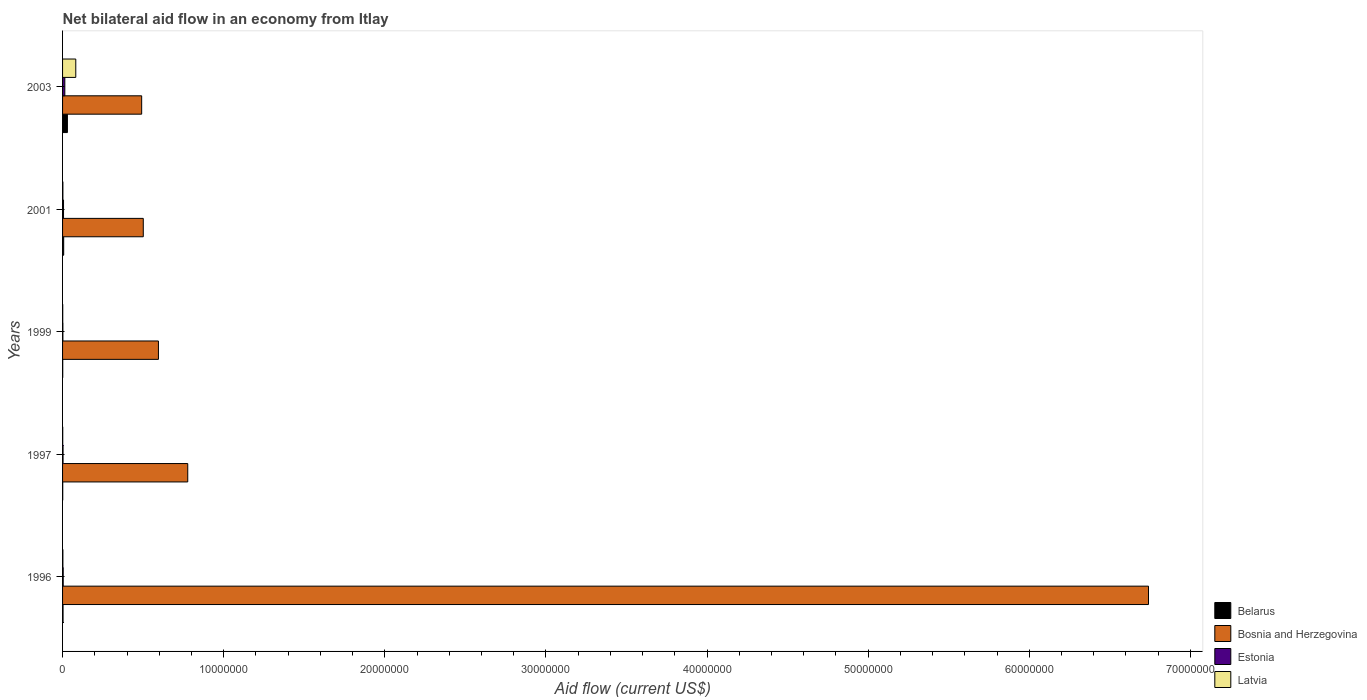How many different coloured bars are there?
Keep it short and to the point. 4. How many groups of bars are there?
Offer a terse response. 5. Are the number of bars per tick equal to the number of legend labels?
Provide a short and direct response. Yes. Are the number of bars on each tick of the Y-axis equal?
Give a very brief answer. Yes. How many bars are there on the 1st tick from the top?
Make the answer very short. 4. How many bars are there on the 4th tick from the bottom?
Offer a terse response. 4. What is the net bilateral aid flow in Belarus in 1999?
Provide a succinct answer. 10000. Across all years, what is the maximum net bilateral aid flow in Bosnia and Herzegovina?
Make the answer very short. 6.74e+07. Across all years, what is the minimum net bilateral aid flow in Estonia?
Provide a short and direct response. 2.00e+04. What is the total net bilateral aid flow in Belarus in the graph?
Ensure brevity in your answer.  4.20e+05. What is the difference between the net bilateral aid flow in Bosnia and Herzegovina in 1997 and that in 2003?
Offer a terse response. 2.86e+06. What is the average net bilateral aid flow in Bosnia and Herzegovina per year?
Offer a very short reply. 1.82e+07. In the year 2003, what is the difference between the net bilateral aid flow in Latvia and net bilateral aid flow in Belarus?
Your response must be concise. 5.20e+05. In how many years, is the net bilateral aid flow in Belarus greater than 68000000 US$?
Provide a succinct answer. 0. What is the ratio of the net bilateral aid flow in Latvia in 1997 to that in 2001?
Ensure brevity in your answer.  0.5. Is the net bilateral aid flow in Estonia in 2001 less than that in 2003?
Make the answer very short. Yes. Is the difference between the net bilateral aid flow in Latvia in 1996 and 1999 greater than the difference between the net bilateral aid flow in Belarus in 1996 and 1999?
Your response must be concise. No. What is the difference between the highest and the second highest net bilateral aid flow in Bosnia and Herzegovina?
Provide a succinct answer. 5.96e+07. In how many years, is the net bilateral aid flow in Estonia greater than the average net bilateral aid flow in Estonia taken over all years?
Your answer should be compact. 2. What does the 2nd bar from the top in 1999 represents?
Ensure brevity in your answer.  Estonia. What does the 4th bar from the bottom in 1999 represents?
Keep it short and to the point. Latvia. Are all the bars in the graph horizontal?
Offer a terse response. Yes. How many years are there in the graph?
Your response must be concise. 5. What is the title of the graph?
Make the answer very short. Net bilateral aid flow in an economy from Itlay. What is the label or title of the Y-axis?
Offer a very short reply. Years. What is the Aid flow (current US$) in Bosnia and Herzegovina in 1996?
Provide a short and direct response. 6.74e+07. What is the Aid flow (current US$) in Estonia in 1996?
Give a very brief answer. 4.00e+04. What is the Aid flow (current US$) in Latvia in 1996?
Your answer should be very brief. 2.00e+04. What is the Aid flow (current US$) in Bosnia and Herzegovina in 1997?
Offer a very short reply. 7.77e+06. What is the Aid flow (current US$) in Estonia in 1997?
Offer a very short reply. 3.00e+04. What is the Aid flow (current US$) of Belarus in 1999?
Make the answer very short. 10000. What is the Aid flow (current US$) of Bosnia and Herzegovina in 1999?
Your answer should be very brief. 5.95e+06. What is the Aid flow (current US$) of Estonia in 1999?
Your answer should be very brief. 2.00e+04. What is the Aid flow (current US$) of Latvia in 1999?
Offer a very short reply. 10000. What is the Aid flow (current US$) of Bosnia and Herzegovina in 2001?
Give a very brief answer. 5.01e+06. What is the Aid flow (current US$) in Estonia in 2001?
Your answer should be very brief. 6.00e+04. What is the Aid flow (current US$) in Latvia in 2001?
Provide a succinct answer. 2.00e+04. What is the Aid flow (current US$) of Belarus in 2003?
Offer a very short reply. 3.00e+05. What is the Aid flow (current US$) of Bosnia and Herzegovina in 2003?
Your answer should be very brief. 4.91e+06. What is the Aid flow (current US$) in Latvia in 2003?
Give a very brief answer. 8.20e+05. Across all years, what is the maximum Aid flow (current US$) of Bosnia and Herzegovina?
Offer a terse response. 6.74e+07. Across all years, what is the maximum Aid flow (current US$) of Latvia?
Keep it short and to the point. 8.20e+05. Across all years, what is the minimum Aid flow (current US$) in Bosnia and Herzegovina?
Keep it short and to the point. 4.91e+06. Across all years, what is the minimum Aid flow (current US$) in Latvia?
Offer a very short reply. 10000. What is the total Aid flow (current US$) of Bosnia and Herzegovina in the graph?
Make the answer very short. 9.10e+07. What is the total Aid flow (current US$) of Estonia in the graph?
Your answer should be compact. 2.90e+05. What is the total Aid flow (current US$) in Latvia in the graph?
Ensure brevity in your answer.  8.80e+05. What is the difference between the Aid flow (current US$) in Bosnia and Herzegovina in 1996 and that in 1997?
Your answer should be compact. 5.96e+07. What is the difference between the Aid flow (current US$) in Latvia in 1996 and that in 1997?
Make the answer very short. 10000. What is the difference between the Aid flow (current US$) in Belarus in 1996 and that in 1999?
Keep it short and to the point. 2.00e+04. What is the difference between the Aid flow (current US$) of Bosnia and Herzegovina in 1996 and that in 1999?
Your response must be concise. 6.14e+07. What is the difference between the Aid flow (current US$) of Latvia in 1996 and that in 1999?
Your answer should be compact. 10000. What is the difference between the Aid flow (current US$) of Belarus in 1996 and that in 2001?
Offer a very short reply. -4.00e+04. What is the difference between the Aid flow (current US$) of Bosnia and Herzegovina in 1996 and that in 2001?
Ensure brevity in your answer.  6.24e+07. What is the difference between the Aid flow (current US$) in Latvia in 1996 and that in 2001?
Provide a short and direct response. 0. What is the difference between the Aid flow (current US$) of Bosnia and Herzegovina in 1996 and that in 2003?
Ensure brevity in your answer.  6.25e+07. What is the difference between the Aid flow (current US$) in Estonia in 1996 and that in 2003?
Ensure brevity in your answer.  -1.00e+05. What is the difference between the Aid flow (current US$) of Latvia in 1996 and that in 2003?
Offer a terse response. -8.00e+05. What is the difference between the Aid flow (current US$) in Belarus in 1997 and that in 1999?
Give a very brief answer. 0. What is the difference between the Aid flow (current US$) in Bosnia and Herzegovina in 1997 and that in 1999?
Provide a succinct answer. 1.82e+06. What is the difference between the Aid flow (current US$) of Estonia in 1997 and that in 1999?
Provide a succinct answer. 10000. What is the difference between the Aid flow (current US$) of Latvia in 1997 and that in 1999?
Ensure brevity in your answer.  0. What is the difference between the Aid flow (current US$) of Belarus in 1997 and that in 2001?
Ensure brevity in your answer.  -6.00e+04. What is the difference between the Aid flow (current US$) of Bosnia and Herzegovina in 1997 and that in 2001?
Offer a very short reply. 2.76e+06. What is the difference between the Aid flow (current US$) of Latvia in 1997 and that in 2001?
Ensure brevity in your answer.  -10000. What is the difference between the Aid flow (current US$) of Belarus in 1997 and that in 2003?
Make the answer very short. -2.90e+05. What is the difference between the Aid flow (current US$) of Bosnia and Herzegovina in 1997 and that in 2003?
Offer a very short reply. 2.86e+06. What is the difference between the Aid flow (current US$) of Latvia in 1997 and that in 2003?
Your answer should be very brief. -8.10e+05. What is the difference between the Aid flow (current US$) in Bosnia and Herzegovina in 1999 and that in 2001?
Offer a terse response. 9.40e+05. What is the difference between the Aid flow (current US$) in Latvia in 1999 and that in 2001?
Your response must be concise. -10000. What is the difference between the Aid flow (current US$) of Bosnia and Herzegovina in 1999 and that in 2003?
Provide a succinct answer. 1.04e+06. What is the difference between the Aid flow (current US$) in Estonia in 1999 and that in 2003?
Give a very brief answer. -1.20e+05. What is the difference between the Aid flow (current US$) in Latvia in 1999 and that in 2003?
Offer a very short reply. -8.10e+05. What is the difference between the Aid flow (current US$) in Latvia in 2001 and that in 2003?
Make the answer very short. -8.00e+05. What is the difference between the Aid flow (current US$) in Belarus in 1996 and the Aid flow (current US$) in Bosnia and Herzegovina in 1997?
Provide a succinct answer. -7.74e+06. What is the difference between the Aid flow (current US$) of Bosnia and Herzegovina in 1996 and the Aid flow (current US$) of Estonia in 1997?
Your answer should be very brief. 6.74e+07. What is the difference between the Aid flow (current US$) in Bosnia and Herzegovina in 1996 and the Aid flow (current US$) in Latvia in 1997?
Provide a short and direct response. 6.74e+07. What is the difference between the Aid flow (current US$) in Estonia in 1996 and the Aid flow (current US$) in Latvia in 1997?
Offer a terse response. 3.00e+04. What is the difference between the Aid flow (current US$) in Belarus in 1996 and the Aid flow (current US$) in Bosnia and Herzegovina in 1999?
Your answer should be very brief. -5.92e+06. What is the difference between the Aid flow (current US$) of Bosnia and Herzegovina in 1996 and the Aid flow (current US$) of Estonia in 1999?
Make the answer very short. 6.74e+07. What is the difference between the Aid flow (current US$) of Bosnia and Herzegovina in 1996 and the Aid flow (current US$) of Latvia in 1999?
Your response must be concise. 6.74e+07. What is the difference between the Aid flow (current US$) of Estonia in 1996 and the Aid flow (current US$) of Latvia in 1999?
Your answer should be very brief. 3.00e+04. What is the difference between the Aid flow (current US$) in Belarus in 1996 and the Aid flow (current US$) in Bosnia and Herzegovina in 2001?
Your answer should be compact. -4.98e+06. What is the difference between the Aid flow (current US$) in Belarus in 1996 and the Aid flow (current US$) in Estonia in 2001?
Make the answer very short. -3.00e+04. What is the difference between the Aid flow (current US$) of Belarus in 1996 and the Aid flow (current US$) of Latvia in 2001?
Give a very brief answer. 10000. What is the difference between the Aid flow (current US$) of Bosnia and Herzegovina in 1996 and the Aid flow (current US$) of Estonia in 2001?
Ensure brevity in your answer.  6.73e+07. What is the difference between the Aid flow (current US$) of Bosnia and Herzegovina in 1996 and the Aid flow (current US$) of Latvia in 2001?
Make the answer very short. 6.74e+07. What is the difference between the Aid flow (current US$) of Estonia in 1996 and the Aid flow (current US$) of Latvia in 2001?
Ensure brevity in your answer.  2.00e+04. What is the difference between the Aid flow (current US$) of Belarus in 1996 and the Aid flow (current US$) of Bosnia and Herzegovina in 2003?
Your response must be concise. -4.88e+06. What is the difference between the Aid flow (current US$) of Belarus in 1996 and the Aid flow (current US$) of Latvia in 2003?
Ensure brevity in your answer.  -7.90e+05. What is the difference between the Aid flow (current US$) of Bosnia and Herzegovina in 1996 and the Aid flow (current US$) of Estonia in 2003?
Your response must be concise. 6.73e+07. What is the difference between the Aid flow (current US$) of Bosnia and Herzegovina in 1996 and the Aid flow (current US$) of Latvia in 2003?
Your response must be concise. 6.66e+07. What is the difference between the Aid flow (current US$) of Estonia in 1996 and the Aid flow (current US$) of Latvia in 2003?
Provide a succinct answer. -7.80e+05. What is the difference between the Aid flow (current US$) of Belarus in 1997 and the Aid flow (current US$) of Bosnia and Herzegovina in 1999?
Provide a succinct answer. -5.94e+06. What is the difference between the Aid flow (current US$) in Belarus in 1997 and the Aid flow (current US$) in Estonia in 1999?
Make the answer very short. -10000. What is the difference between the Aid flow (current US$) of Belarus in 1997 and the Aid flow (current US$) of Latvia in 1999?
Keep it short and to the point. 0. What is the difference between the Aid flow (current US$) of Bosnia and Herzegovina in 1997 and the Aid flow (current US$) of Estonia in 1999?
Your answer should be compact. 7.75e+06. What is the difference between the Aid flow (current US$) in Bosnia and Herzegovina in 1997 and the Aid flow (current US$) in Latvia in 1999?
Ensure brevity in your answer.  7.76e+06. What is the difference between the Aid flow (current US$) of Belarus in 1997 and the Aid flow (current US$) of Bosnia and Herzegovina in 2001?
Provide a succinct answer. -5.00e+06. What is the difference between the Aid flow (current US$) in Belarus in 1997 and the Aid flow (current US$) in Estonia in 2001?
Provide a succinct answer. -5.00e+04. What is the difference between the Aid flow (current US$) of Bosnia and Herzegovina in 1997 and the Aid flow (current US$) of Estonia in 2001?
Provide a succinct answer. 7.71e+06. What is the difference between the Aid flow (current US$) in Bosnia and Herzegovina in 1997 and the Aid flow (current US$) in Latvia in 2001?
Give a very brief answer. 7.75e+06. What is the difference between the Aid flow (current US$) of Belarus in 1997 and the Aid flow (current US$) of Bosnia and Herzegovina in 2003?
Provide a short and direct response. -4.90e+06. What is the difference between the Aid flow (current US$) in Belarus in 1997 and the Aid flow (current US$) in Latvia in 2003?
Make the answer very short. -8.10e+05. What is the difference between the Aid flow (current US$) in Bosnia and Herzegovina in 1997 and the Aid flow (current US$) in Estonia in 2003?
Keep it short and to the point. 7.63e+06. What is the difference between the Aid flow (current US$) of Bosnia and Herzegovina in 1997 and the Aid flow (current US$) of Latvia in 2003?
Your response must be concise. 6.95e+06. What is the difference between the Aid flow (current US$) in Estonia in 1997 and the Aid flow (current US$) in Latvia in 2003?
Ensure brevity in your answer.  -7.90e+05. What is the difference between the Aid flow (current US$) in Belarus in 1999 and the Aid flow (current US$) in Bosnia and Herzegovina in 2001?
Make the answer very short. -5.00e+06. What is the difference between the Aid flow (current US$) in Belarus in 1999 and the Aid flow (current US$) in Estonia in 2001?
Keep it short and to the point. -5.00e+04. What is the difference between the Aid flow (current US$) in Belarus in 1999 and the Aid flow (current US$) in Latvia in 2001?
Your answer should be compact. -10000. What is the difference between the Aid flow (current US$) of Bosnia and Herzegovina in 1999 and the Aid flow (current US$) of Estonia in 2001?
Provide a short and direct response. 5.89e+06. What is the difference between the Aid flow (current US$) of Bosnia and Herzegovina in 1999 and the Aid flow (current US$) of Latvia in 2001?
Make the answer very short. 5.93e+06. What is the difference between the Aid flow (current US$) of Estonia in 1999 and the Aid flow (current US$) of Latvia in 2001?
Offer a terse response. 0. What is the difference between the Aid flow (current US$) in Belarus in 1999 and the Aid flow (current US$) in Bosnia and Herzegovina in 2003?
Offer a very short reply. -4.90e+06. What is the difference between the Aid flow (current US$) in Belarus in 1999 and the Aid flow (current US$) in Estonia in 2003?
Offer a very short reply. -1.30e+05. What is the difference between the Aid flow (current US$) of Belarus in 1999 and the Aid flow (current US$) of Latvia in 2003?
Provide a succinct answer. -8.10e+05. What is the difference between the Aid flow (current US$) of Bosnia and Herzegovina in 1999 and the Aid flow (current US$) of Estonia in 2003?
Your answer should be compact. 5.81e+06. What is the difference between the Aid flow (current US$) of Bosnia and Herzegovina in 1999 and the Aid flow (current US$) of Latvia in 2003?
Provide a succinct answer. 5.13e+06. What is the difference between the Aid flow (current US$) of Estonia in 1999 and the Aid flow (current US$) of Latvia in 2003?
Your answer should be very brief. -8.00e+05. What is the difference between the Aid flow (current US$) of Belarus in 2001 and the Aid flow (current US$) of Bosnia and Herzegovina in 2003?
Keep it short and to the point. -4.84e+06. What is the difference between the Aid flow (current US$) of Belarus in 2001 and the Aid flow (current US$) of Latvia in 2003?
Keep it short and to the point. -7.50e+05. What is the difference between the Aid flow (current US$) of Bosnia and Herzegovina in 2001 and the Aid flow (current US$) of Estonia in 2003?
Your answer should be very brief. 4.87e+06. What is the difference between the Aid flow (current US$) in Bosnia and Herzegovina in 2001 and the Aid flow (current US$) in Latvia in 2003?
Your response must be concise. 4.19e+06. What is the difference between the Aid flow (current US$) of Estonia in 2001 and the Aid flow (current US$) of Latvia in 2003?
Offer a very short reply. -7.60e+05. What is the average Aid flow (current US$) of Belarus per year?
Ensure brevity in your answer.  8.40e+04. What is the average Aid flow (current US$) of Bosnia and Herzegovina per year?
Make the answer very short. 1.82e+07. What is the average Aid flow (current US$) of Estonia per year?
Keep it short and to the point. 5.80e+04. What is the average Aid flow (current US$) in Latvia per year?
Make the answer very short. 1.76e+05. In the year 1996, what is the difference between the Aid flow (current US$) of Belarus and Aid flow (current US$) of Bosnia and Herzegovina?
Your response must be concise. -6.74e+07. In the year 1996, what is the difference between the Aid flow (current US$) in Belarus and Aid flow (current US$) in Latvia?
Keep it short and to the point. 10000. In the year 1996, what is the difference between the Aid flow (current US$) in Bosnia and Herzegovina and Aid flow (current US$) in Estonia?
Provide a succinct answer. 6.74e+07. In the year 1996, what is the difference between the Aid flow (current US$) in Bosnia and Herzegovina and Aid flow (current US$) in Latvia?
Give a very brief answer. 6.74e+07. In the year 1997, what is the difference between the Aid flow (current US$) of Belarus and Aid flow (current US$) of Bosnia and Herzegovina?
Your answer should be very brief. -7.76e+06. In the year 1997, what is the difference between the Aid flow (current US$) in Belarus and Aid flow (current US$) in Estonia?
Make the answer very short. -2.00e+04. In the year 1997, what is the difference between the Aid flow (current US$) of Belarus and Aid flow (current US$) of Latvia?
Provide a succinct answer. 0. In the year 1997, what is the difference between the Aid flow (current US$) of Bosnia and Herzegovina and Aid flow (current US$) of Estonia?
Keep it short and to the point. 7.74e+06. In the year 1997, what is the difference between the Aid flow (current US$) of Bosnia and Herzegovina and Aid flow (current US$) of Latvia?
Give a very brief answer. 7.76e+06. In the year 1999, what is the difference between the Aid flow (current US$) in Belarus and Aid flow (current US$) in Bosnia and Herzegovina?
Offer a very short reply. -5.94e+06. In the year 1999, what is the difference between the Aid flow (current US$) in Belarus and Aid flow (current US$) in Estonia?
Make the answer very short. -10000. In the year 1999, what is the difference between the Aid flow (current US$) of Bosnia and Herzegovina and Aid flow (current US$) of Estonia?
Offer a very short reply. 5.93e+06. In the year 1999, what is the difference between the Aid flow (current US$) in Bosnia and Herzegovina and Aid flow (current US$) in Latvia?
Your answer should be very brief. 5.94e+06. In the year 2001, what is the difference between the Aid flow (current US$) of Belarus and Aid flow (current US$) of Bosnia and Herzegovina?
Provide a short and direct response. -4.94e+06. In the year 2001, what is the difference between the Aid flow (current US$) of Belarus and Aid flow (current US$) of Latvia?
Offer a very short reply. 5.00e+04. In the year 2001, what is the difference between the Aid flow (current US$) in Bosnia and Herzegovina and Aid flow (current US$) in Estonia?
Your answer should be compact. 4.95e+06. In the year 2001, what is the difference between the Aid flow (current US$) in Bosnia and Herzegovina and Aid flow (current US$) in Latvia?
Give a very brief answer. 4.99e+06. In the year 2001, what is the difference between the Aid flow (current US$) in Estonia and Aid flow (current US$) in Latvia?
Provide a short and direct response. 4.00e+04. In the year 2003, what is the difference between the Aid flow (current US$) in Belarus and Aid flow (current US$) in Bosnia and Herzegovina?
Your response must be concise. -4.61e+06. In the year 2003, what is the difference between the Aid flow (current US$) of Belarus and Aid flow (current US$) of Estonia?
Your answer should be compact. 1.60e+05. In the year 2003, what is the difference between the Aid flow (current US$) of Belarus and Aid flow (current US$) of Latvia?
Provide a short and direct response. -5.20e+05. In the year 2003, what is the difference between the Aid flow (current US$) in Bosnia and Herzegovina and Aid flow (current US$) in Estonia?
Ensure brevity in your answer.  4.77e+06. In the year 2003, what is the difference between the Aid flow (current US$) in Bosnia and Herzegovina and Aid flow (current US$) in Latvia?
Provide a succinct answer. 4.09e+06. In the year 2003, what is the difference between the Aid flow (current US$) of Estonia and Aid flow (current US$) of Latvia?
Your answer should be very brief. -6.80e+05. What is the ratio of the Aid flow (current US$) of Belarus in 1996 to that in 1997?
Give a very brief answer. 3. What is the ratio of the Aid flow (current US$) in Bosnia and Herzegovina in 1996 to that in 1997?
Your response must be concise. 8.67. What is the ratio of the Aid flow (current US$) of Latvia in 1996 to that in 1997?
Keep it short and to the point. 2. What is the ratio of the Aid flow (current US$) in Belarus in 1996 to that in 1999?
Your response must be concise. 3. What is the ratio of the Aid flow (current US$) in Bosnia and Herzegovina in 1996 to that in 1999?
Provide a short and direct response. 11.33. What is the ratio of the Aid flow (current US$) in Belarus in 1996 to that in 2001?
Keep it short and to the point. 0.43. What is the ratio of the Aid flow (current US$) of Bosnia and Herzegovina in 1996 to that in 2001?
Give a very brief answer. 13.45. What is the ratio of the Aid flow (current US$) in Belarus in 1996 to that in 2003?
Make the answer very short. 0.1. What is the ratio of the Aid flow (current US$) of Bosnia and Herzegovina in 1996 to that in 2003?
Keep it short and to the point. 13.73. What is the ratio of the Aid flow (current US$) in Estonia in 1996 to that in 2003?
Make the answer very short. 0.29. What is the ratio of the Aid flow (current US$) of Latvia in 1996 to that in 2003?
Give a very brief answer. 0.02. What is the ratio of the Aid flow (current US$) of Bosnia and Herzegovina in 1997 to that in 1999?
Offer a very short reply. 1.31. What is the ratio of the Aid flow (current US$) in Belarus in 1997 to that in 2001?
Make the answer very short. 0.14. What is the ratio of the Aid flow (current US$) in Bosnia and Herzegovina in 1997 to that in 2001?
Your answer should be compact. 1.55. What is the ratio of the Aid flow (current US$) of Estonia in 1997 to that in 2001?
Your answer should be very brief. 0.5. What is the ratio of the Aid flow (current US$) in Latvia in 1997 to that in 2001?
Offer a terse response. 0.5. What is the ratio of the Aid flow (current US$) of Bosnia and Herzegovina in 1997 to that in 2003?
Ensure brevity in your answer.  1.58. What is the ratio of the Aid flow (current US$) in Estonia in 1997 to that in 2003?
Offer a terse response. 0.21. What is the ratio of the Aid flow (current US$) of Latvia in 1997 to that in 2003?
Offer a terse response. 0.01. What is the ratio of the Aid flow (current US$) of Belarus in 1999 to that in 2001?
Your answer should be compact. 0.14. What is the ratio of the Aid flow (current US$) of Bosnia and Herzegovina in 1999 to that in 2001?
Your answer should be very brief. 1.19. What is the ratio of the Aid flow (current US$) in Belarus in 1999 to that in 2003?
Your response must be concise. 0.03. What is the ratio of the Aid flow (current US$) of Bosnia and Herzegovina in 1999 to that in 2003?
Provide a short and direct response. 1.21. What is the ratio of the Aid flow (current US$) in Estonia in 1999 to that in 2003?
Make the answer very short. 0.14. What is the ratio of the Aid flow (current US$) in Latvia in 1999 to that in 2003?
Ensure brevity in your answer.  0.01. What is the ratio of the Aid flow (current US$) in Belarus in 2001 to that in 2003?
Make the answer very short. 0.23. What is the ratio of the Aid flow (current US$) of Bosnia and Herzegovina in 2001 to that in 2003?
Make the answer very short. 1.02. What is the ratio of the Aid flow (current US$) in Estonia in 2001 to that in 2003?
Offer a very short reply. 0.43. What is the ratio of the Aid flow (current US$) in Latvia in 2001 to that in 2003?
Ensure brevity in your answer.  0.02. What is the difference between the highest and the second highest Aid flow (current US$) of Bosnia and Herzegovina?
Provide a succinct answer. 5.96e+07. What is the difference between the highest and the second highest Aid flow (current US$) of Estonia?
Provide a succinct answer. 8.00e+04. What is the difference between the highest and the lowest Aid flow (current US$) of Belarus?
Keep it short and to the point. 2.90e+05. What is the difference between the highest and the lowest Aid flow (current US$) in Bosnia and Herzegovina?
Your answer should be compact. 6.25e+07. What is the difference between the highest and the lowest Aid flow (current US$) of Estonia?
Offer a terse response. 1.20e+05. What is the difference between the highest and the lowest Aid flow (current US$) of Latvia?
Offer a terse response. 8.10e+05. 